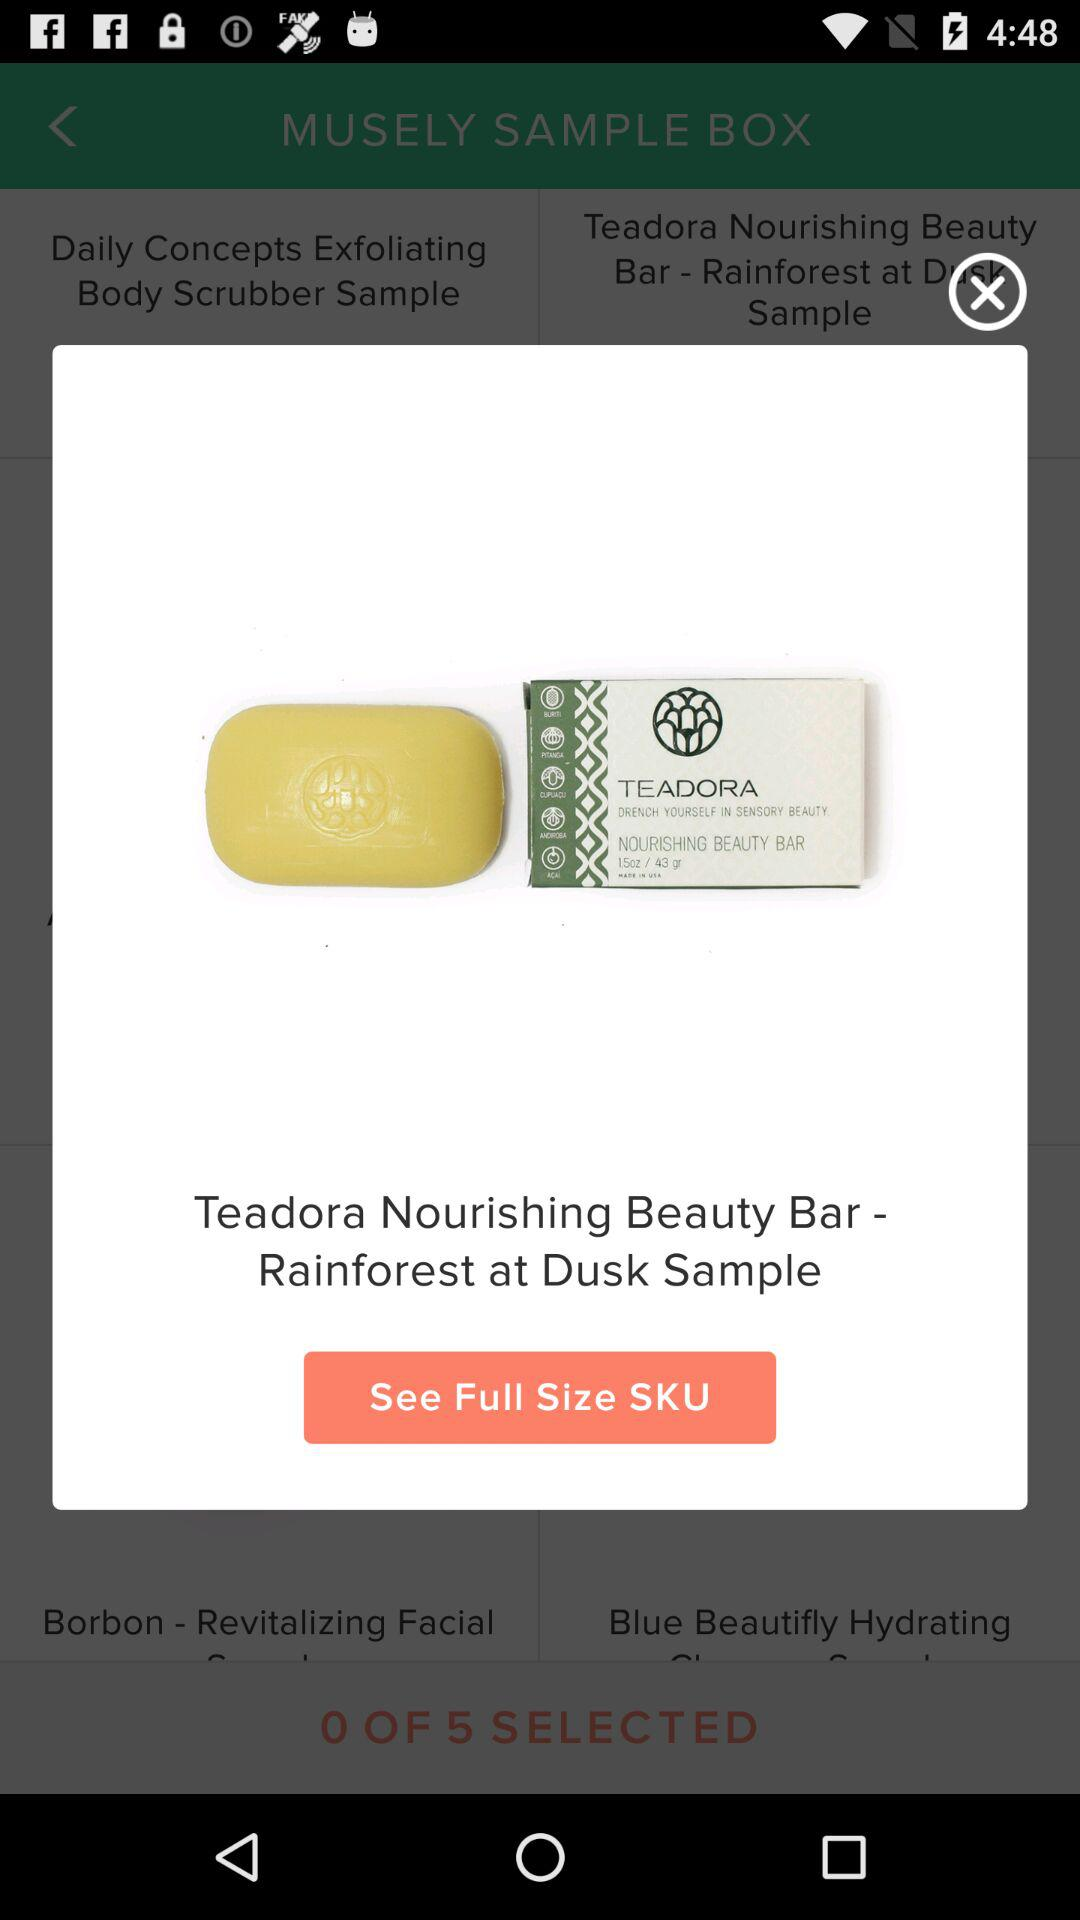What is the soap name? The soap name is "Teadora Nourishing Beauty Bar - Rainforest at Dusk Sample". 